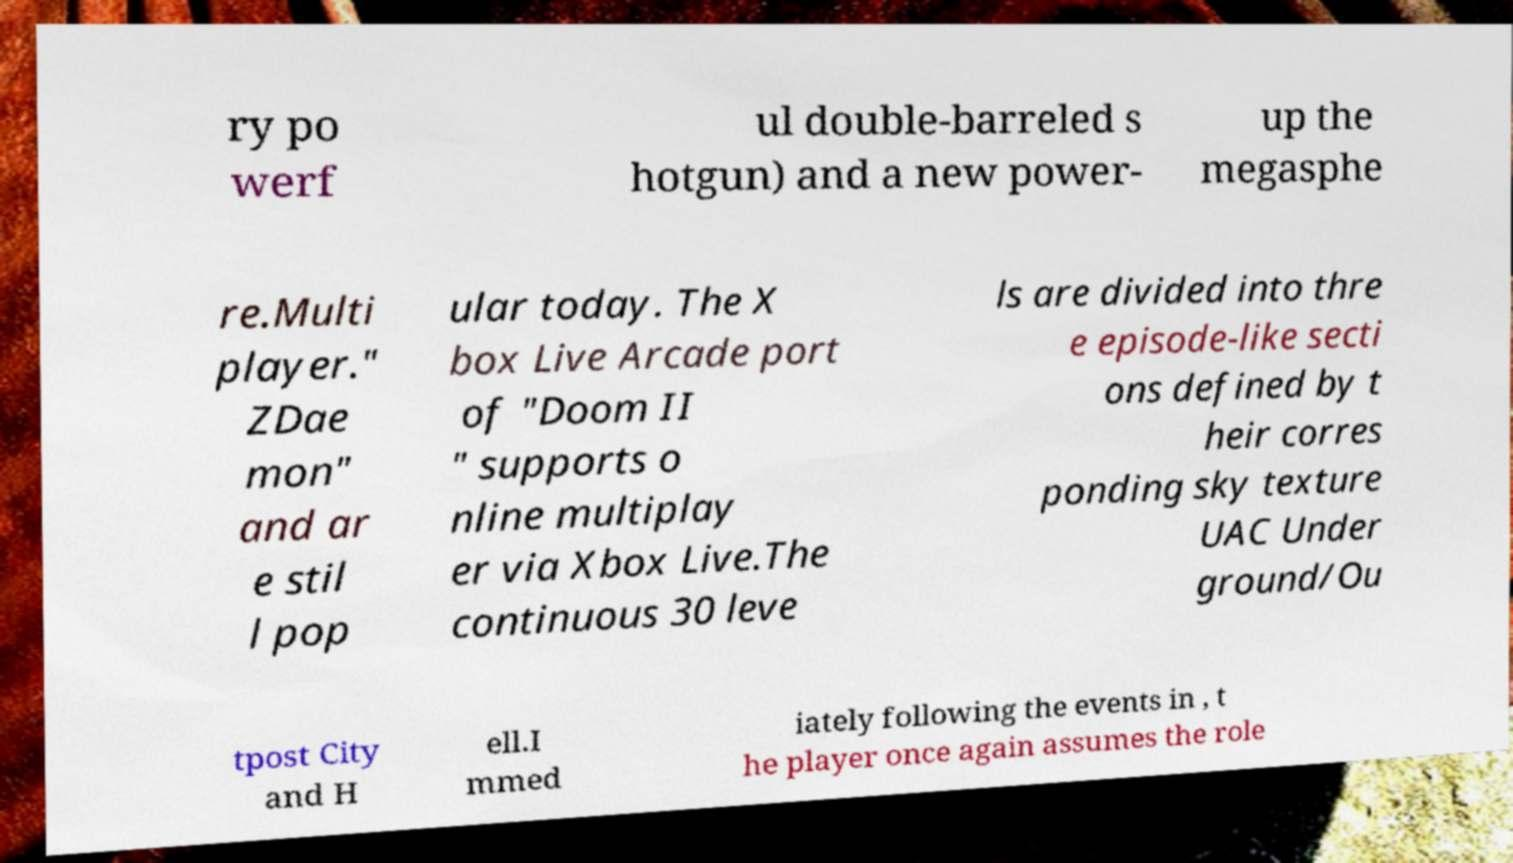There's text embedded in this image that I need extracted. Can you transcribe it verbatim? ry po werf ul double-barreled s hotgun) and a new power- up the megasphe re.Multi player." ZDae mon" and ar e stil l pop ular today. The X box Live Arcade port of "Doom II " supports o nline multiplay er via Xbox Live.The continuous 30 leve ls are divided into thre e episode-like secti ons defined by t heir corres ponding sky texture UAC Under ground/Ou tpost City and H ell.I mmed iately following the events in , t he player once again assumes the role 